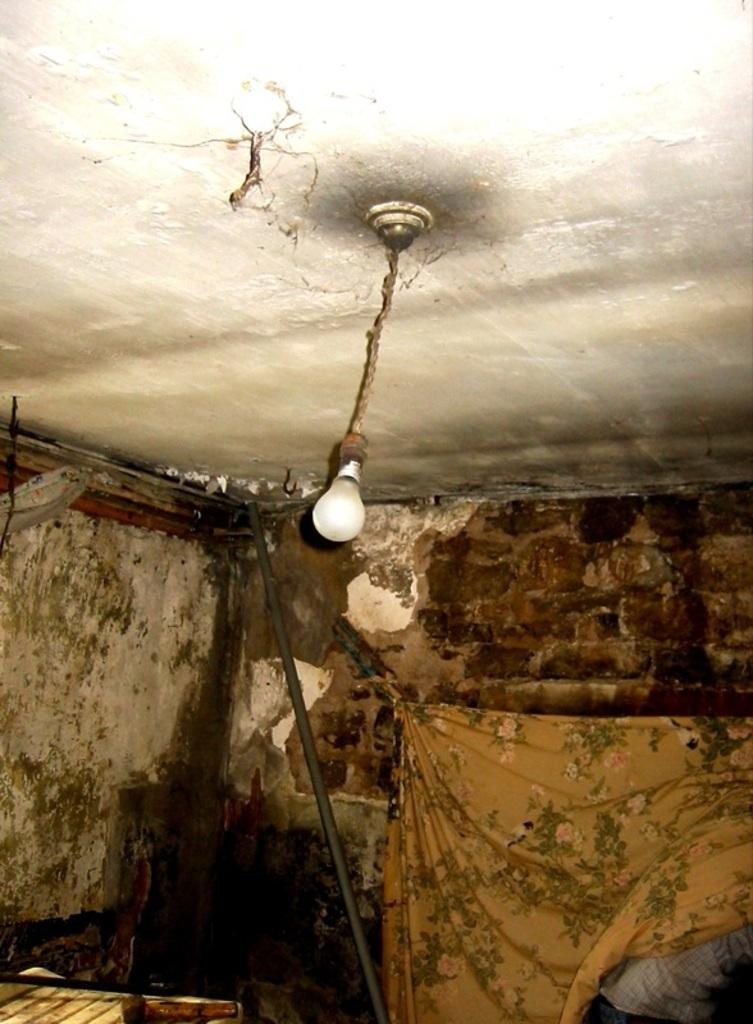What is located in the middle of the image? There is a bulb in the middle of the image. What else can be seen in the image? There is a wall in the image. What type of appliance is visible in the image? There is no appliance present in the image. Is there a rifle visible in the image? There is no rifle present in the image. Can you see a basin in the image? There is no basin present in the image. 